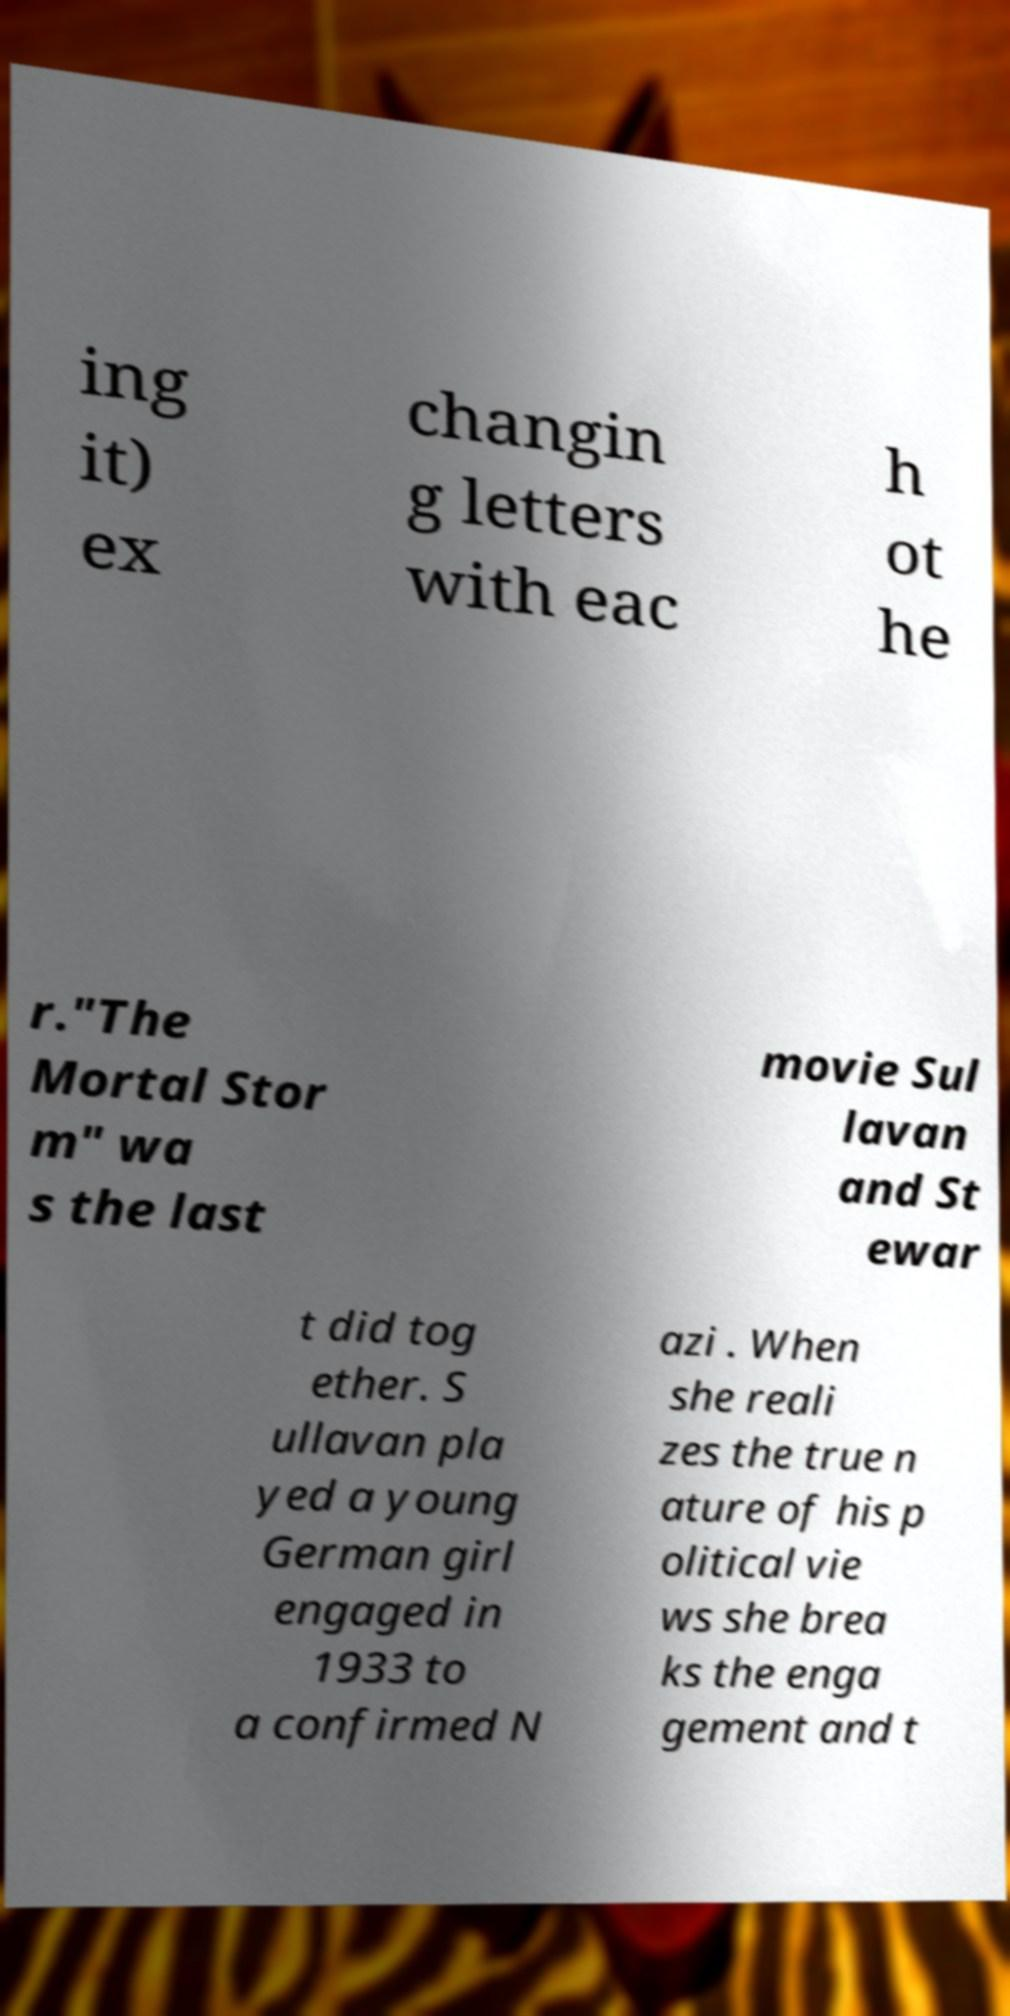Can you accurately transcribe the text from the provided image for me? ing it) ex changin g letters with eac h ot he r."The Mortal Stor m" wa s the last movie Sul lavan and St ewar t did tog ether. S ullavan pla yed a young German girl engaged in 1933 to a confirmed N azi . When she reali zes the true n ature of his p olitical vie ws she brea ks the enga gement and t 